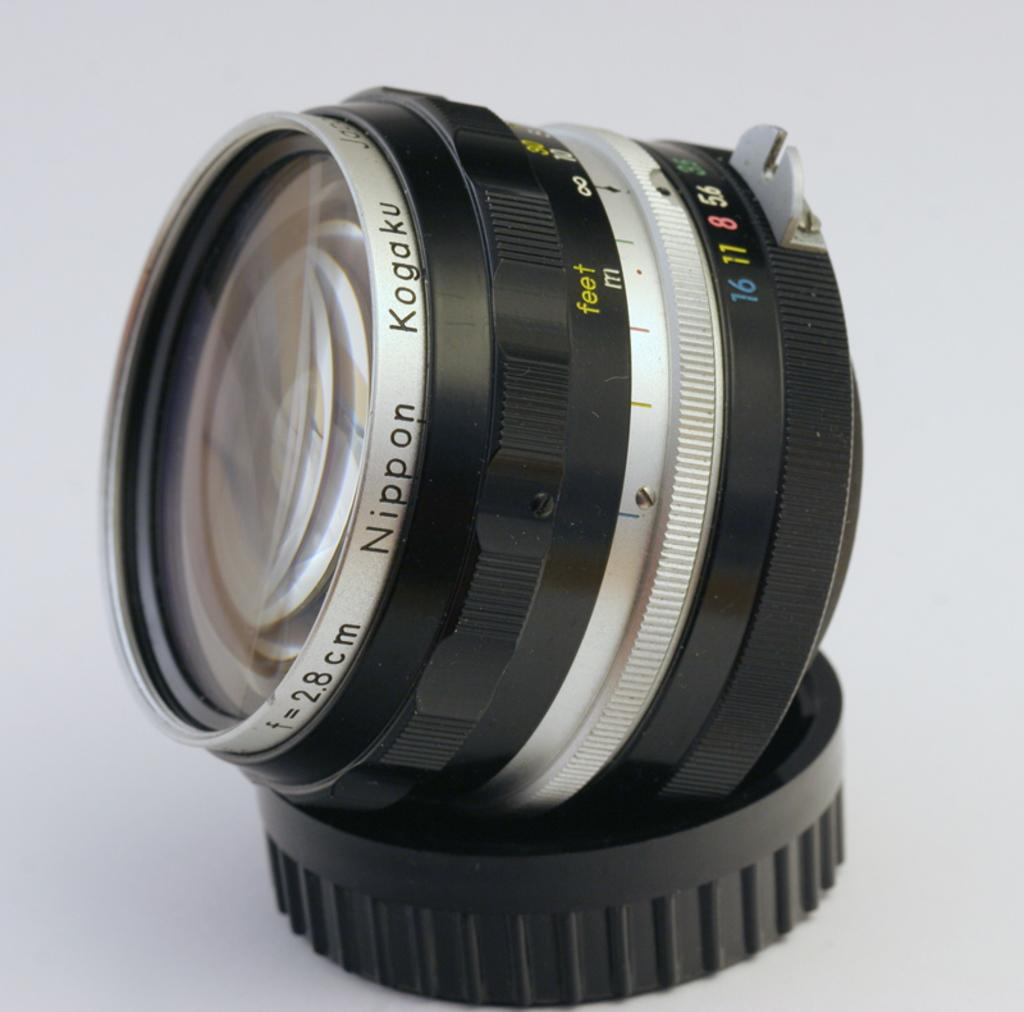What is the main subject of the picture? The main subject of the picture is a camera lens. Does the camera lens have any specific features? Yes, the camera lens has a lid. What is the color of the surface on which the camera lens and its lid are placed? The camera lens and its lid are placed on a white surface. What type of linen is being used by the committee in the image? There is no committee or linen present in the image; it only features a camera lens and its lid on a white surface. 